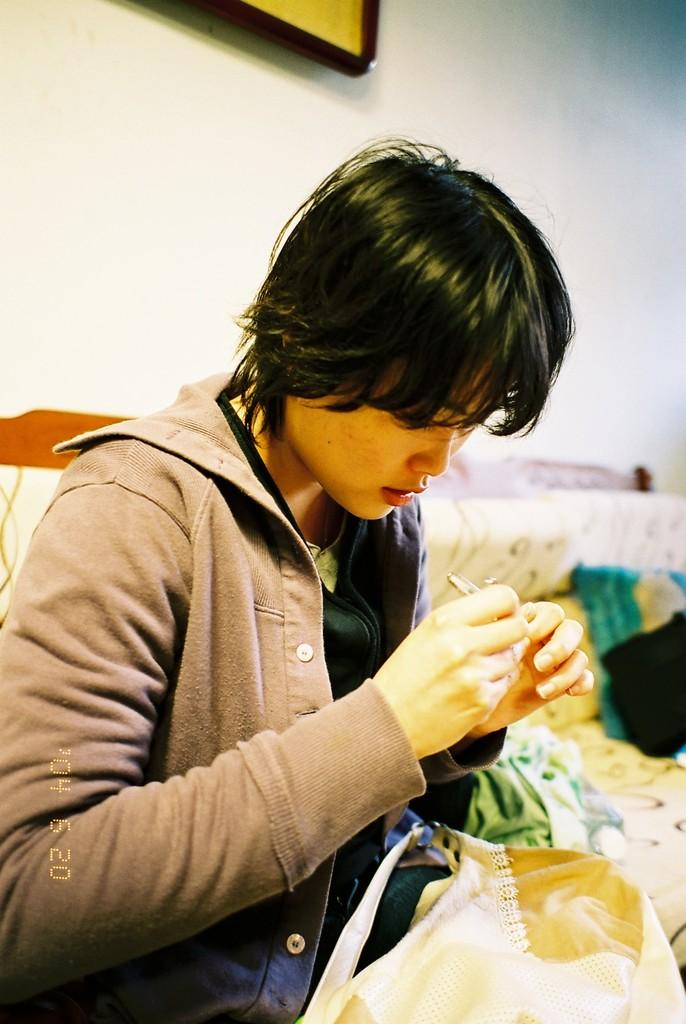What is the person in the image doing? The person is cutting his nails. What is the person wearing in the image? The person is wearing a jacket. Where is the person sitting in the image? The person is sitting on a sofa. What can be seen at the top of the image? There is a photo frame at the top of the image. What type of farm animals can be seen in the image? There are no farm animals present in the image. What is the person using to water the plants in the image? There are no plants or watering tools present in the image. 